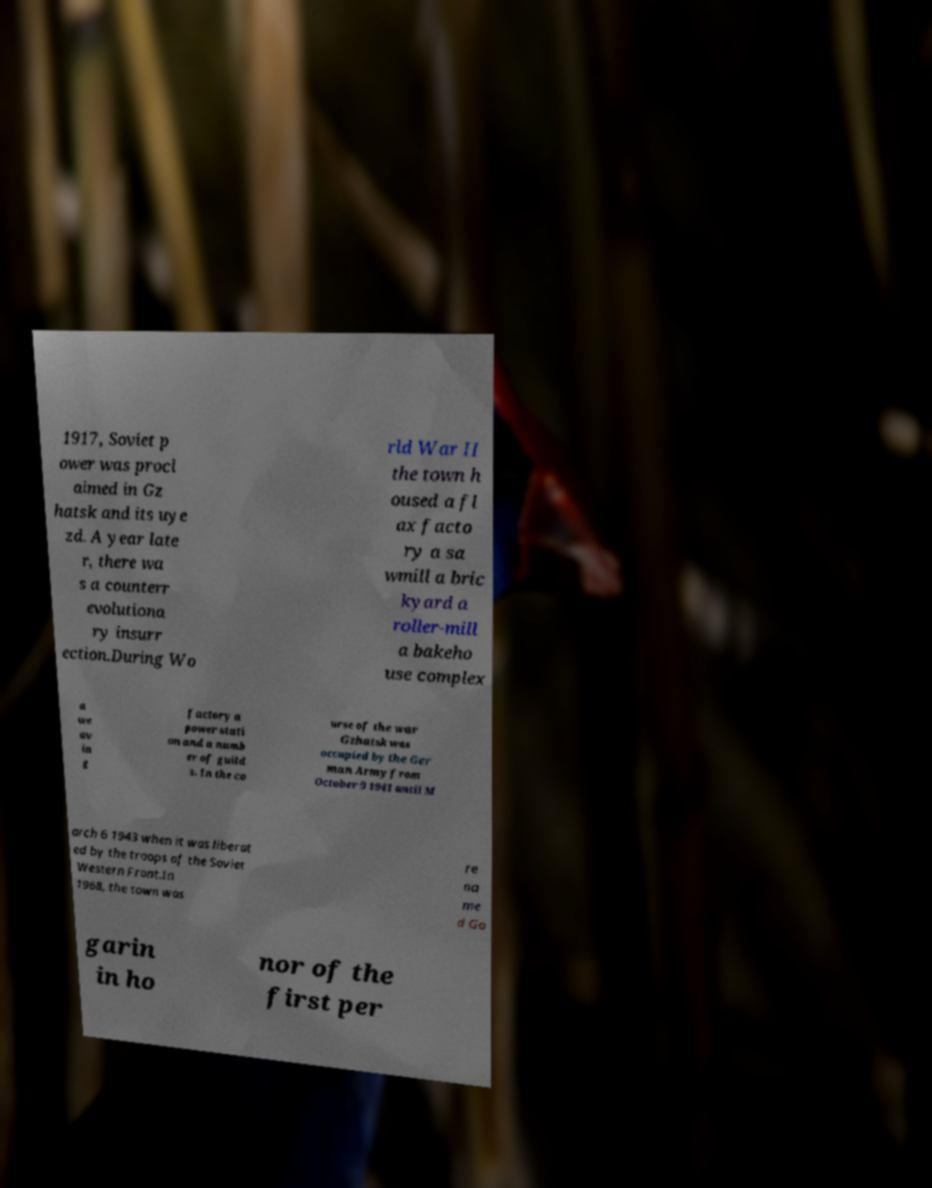Could you extract and type out the text from this image? 1917, Soviet p ower was procl aimed in Gz hatsk and its uye zd. A year late r, there wa s a counterr evolutiona ry insurr ection.During Wo rld War II the town h oused a fl ax facto ry a sa wmill a bric kyard a roller-mill a bakeho use complex a we av in g factory a power stati on and a numb er of guild s. In the co urse of the war Gzhatsk was occupied by the Ger man Army from October 9 1941 until M arch 6 1943 when it was liberat ed by the troops of the Soviet Western Front.In 1968, the town was re na me d Ga garin in ho nor of the first per 